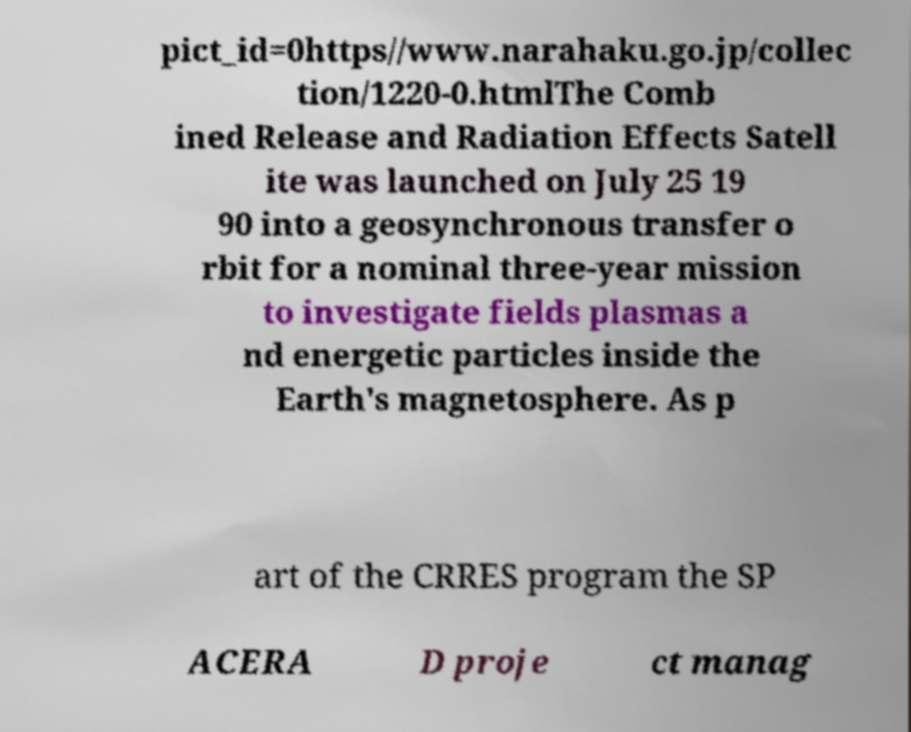What messages or text are displayed in this image? I need them in a readable, typed format. pict_id=0https//www.narahaku.go.jp/collec tion/1220-0.htmlThe Comb ined Release and Radiation Effects Satell ite was launched on July 25 19 90 into a geosynchronous transfer o rbit for a nominal three-year mission to investigate fields plasmas a nd energetic particles inside the Earth's magnetosphere. As p art of the CRRES program the SP ACERA D proje ct manag 